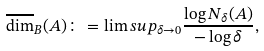<formula> <loc_0><loc_0><loc_500><loc_500>\overline { \dim } _ { B } ( A ) \colon = \lim s u p _ { \delta \to 0 } \frac { \log N _ { \delta } ( A ) } { - \log \delta } ,</formula> 